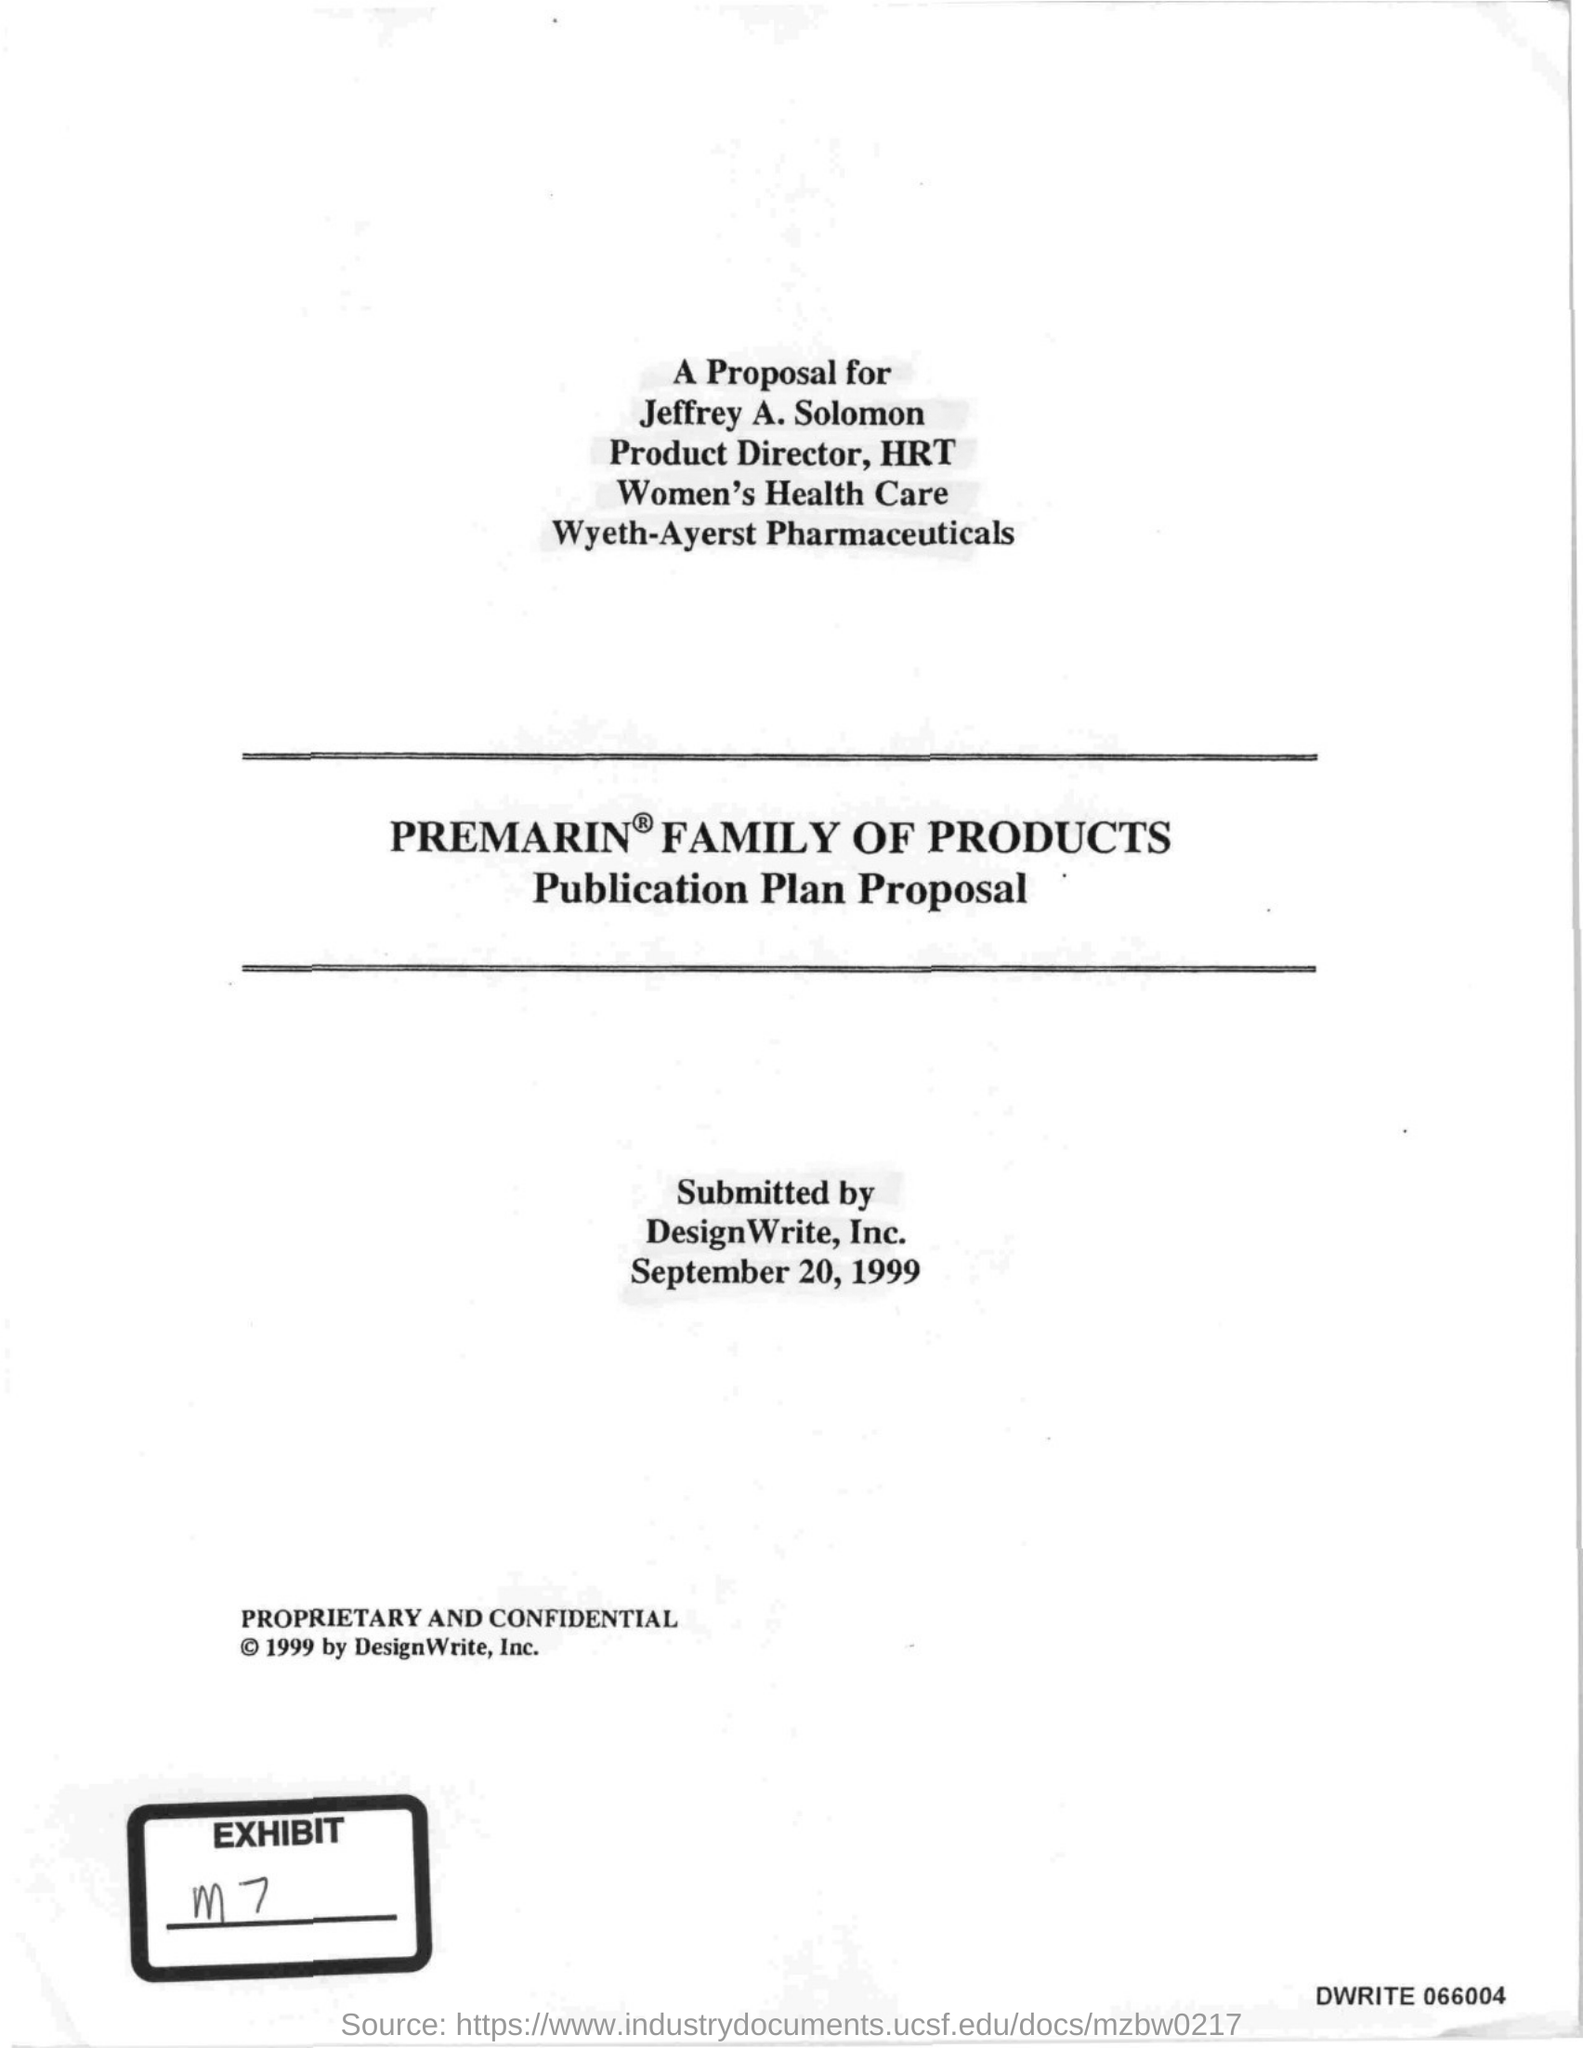For whom is the proposal?
Offer a terse response. Jeffrey A. Solomon. By whom was the proposal submitted?
Provide a succinct answer. DesignWrite, Inc. When was the proposal submitted?
Offer a terse response. September 20, 1999. 